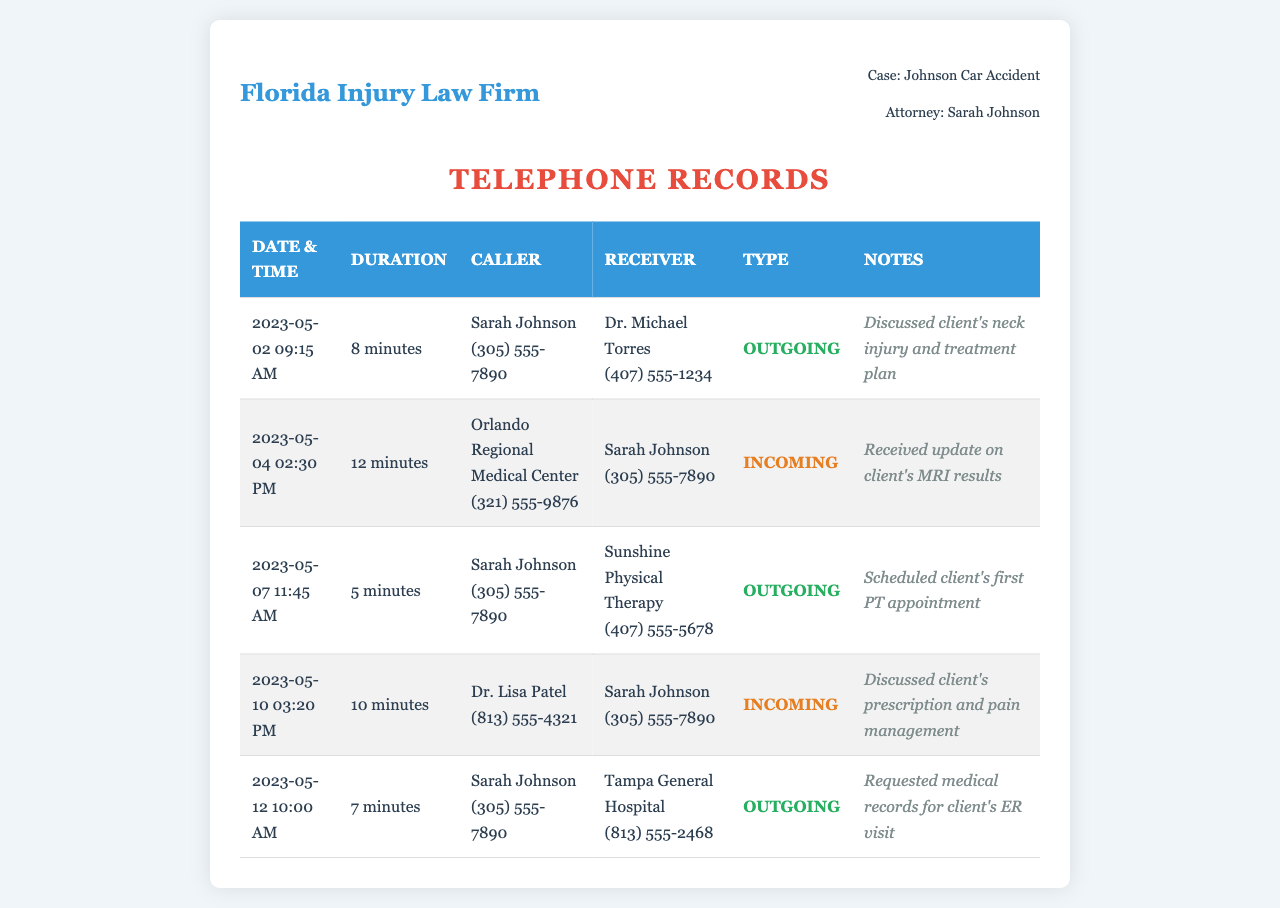what is the total number of calls listed? The document contains a list of calls, and we can count each entry in the table to find the total. There are 5 entries.
Answer: 5 who is the attorney representing the case? The document mentions the name of the attorney in the case information section. The attorney's name is Sarah Johnson.
Answer: Sarah Johnson what was discussed in the call on May 2, 2023? The notes column specifies the content of the call made on that date, which includes a discussion about the client's neck injury and treatment.
Answer: Client's neck injury and treatment plan how long was the call with Tampa General Hospital? The duration of the call is given in the duration column for that date, allowing us to specify the duration of the interaction. The call lasted 7 minutes.
Answer: 7 minutes who received the update about the client's MRI results? The document provides information on who received the call on a specific date, indicating the person who received the update regarding the MRI results.
Answer: Sarah Johnson how many incoming calls are recorded? We can analyze the calls to determine how many were incoming by checking the type column for every entry and counting the occurrences. There are 2 incoming calls.
Answer: 2 what type of call was made to Dr. Lisa Patel? The call type is indicated in the document, providing clarity on the nature of the communication with Dr. Lisa Patel. It was an incoming call.
Answer: Incoming which medical facility was contacted for the client's ER visit? The notes section provides information on which facility's records were requested, as indicated in the communication with the number listed.
Answer: Tampa General Hospital what was the date of the call for scheduling the first PT appointment? The date of the call is provided in the date and time column, and checking that entry gives us the specific date for the scheduling.
Answer: May 7, 2023 